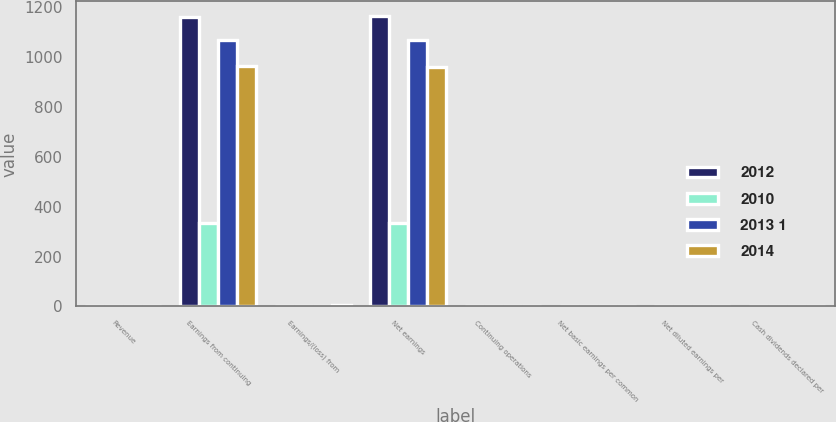Convert chart to OTSL. <chart><loc_0><loc_0><loc_500><loc_500><stacked_bar_chart><ecel><fcel>Revenue<fcel>Earnings from continuing<fcel>Earnings/(loss) from<fcel>Net earnings<fcel>Continuing operations<fcel>Net basic earnings per common<fcel>Net diluted earnings per<fcel>Cash dividends declared per<nl><fcel>2012<fcel>3.08<fcel>1163<fcel>3<fcel>1166<fcel>3.41<fcel>3.42<fcel>3.38<fcel>1.25<nl><fcel>2010<fcel>3.08<fcel>335<fcel>1<fcel>334<fcel>0.98<fcel>0.98<fcel>0.97<fcel>1.09<nl><fcel>2013 1<fcel>3.08<fcel>1070<fcel>1<fcel>1069<fcel>3.1<fcel>3.1<fcel>3.06<fcel>0.88<nl><fcel>2014<fcel>3.08<fcel>966<fcel>7<fcel>959<fcel>2.77<fcel>2.75<fcel>2.72<fcel>0.8<nl></chart> 